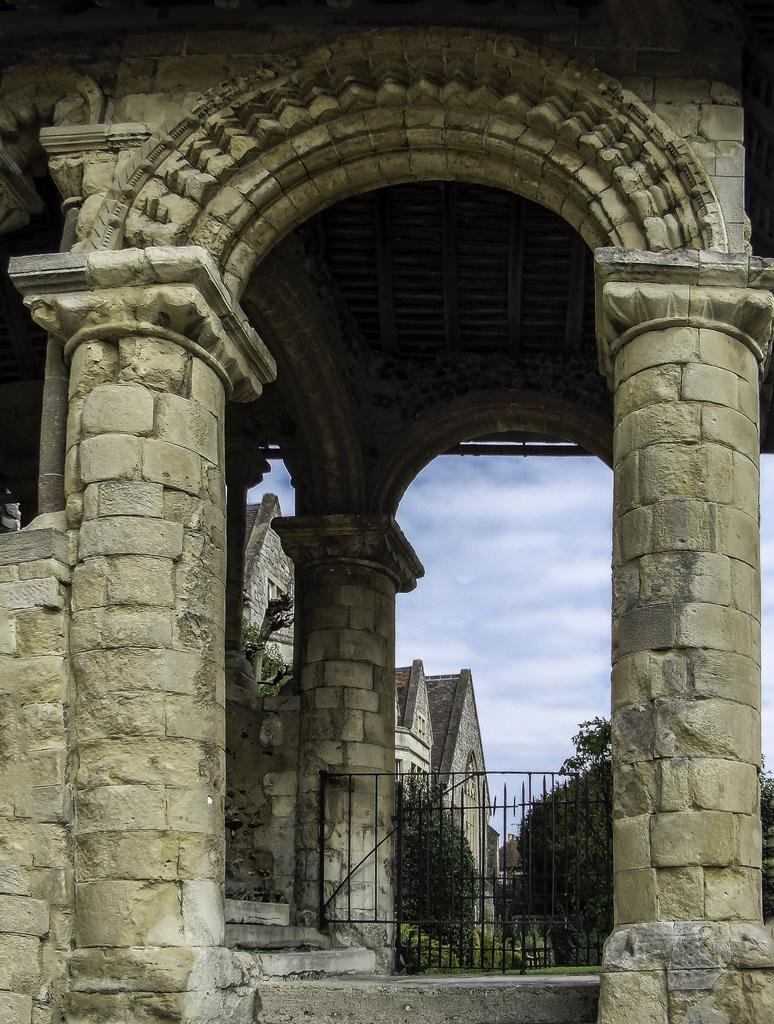What architectural features can be seen in the image? There are pillars and a wall visible in the image. What type of structure is present in the image? There is a grille in the image. What can be seen through the grille? Trees, grass, and plants can be seen through the grille. What is visible in the background of the image? There are buildings and the sky visible in the background of the image. What type of zinc is present in the image? There is no zinc present in the image. What suggestion is being made in the image? There is no suggestion being made in the image; it is a static representation of the scene. 